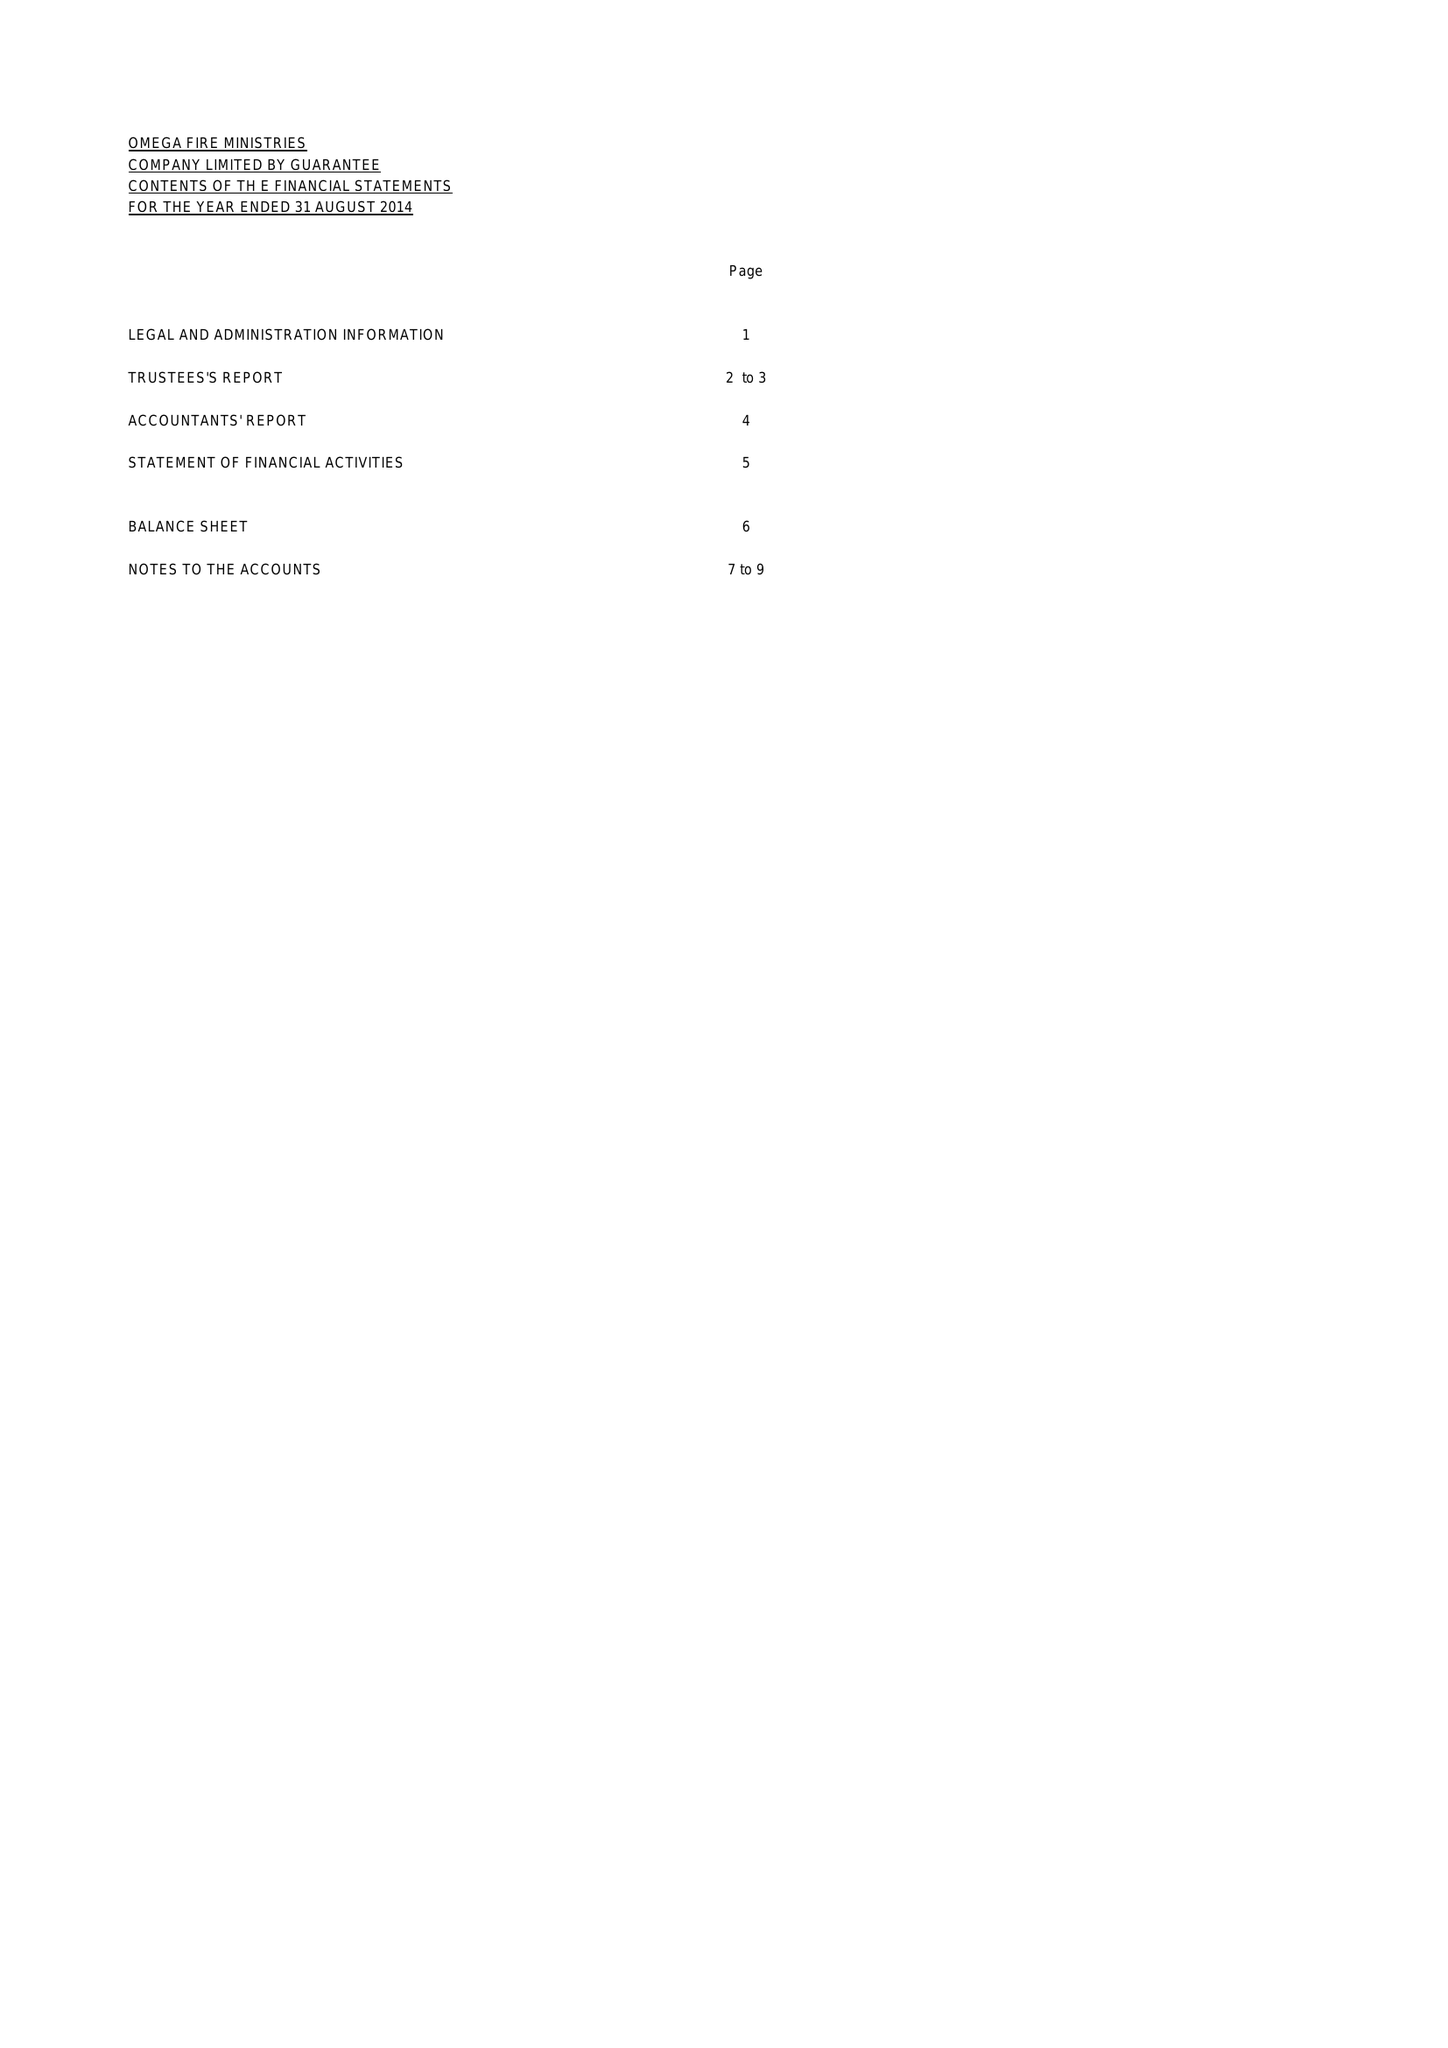What is the value for the address__postcode?
Answer the question using a single word or phrase. RM8 3LR 